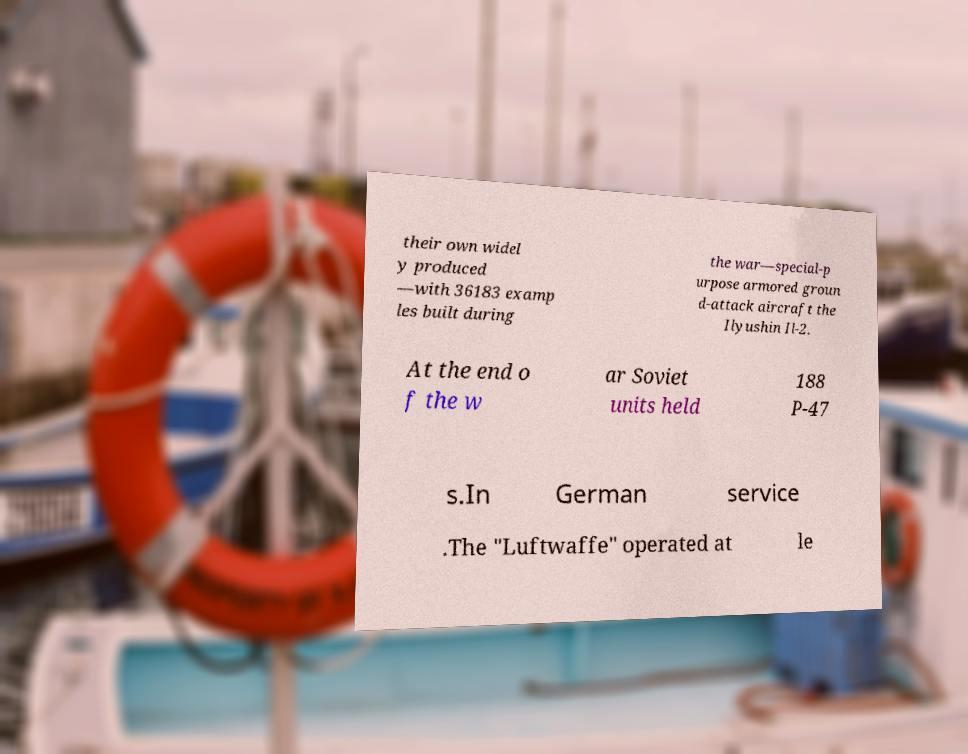For documentation purposes, I need the text within this image transcribed. Could you provide that? their own widel y produced —with 36183 examp les built during the war—special-p urpose armored groun d-attack aircraft the Ilyushin Il-2. At the end o f the w ar Soviet units held 188 P-47 s.In German service .The "Luftwaffe" operated at le 